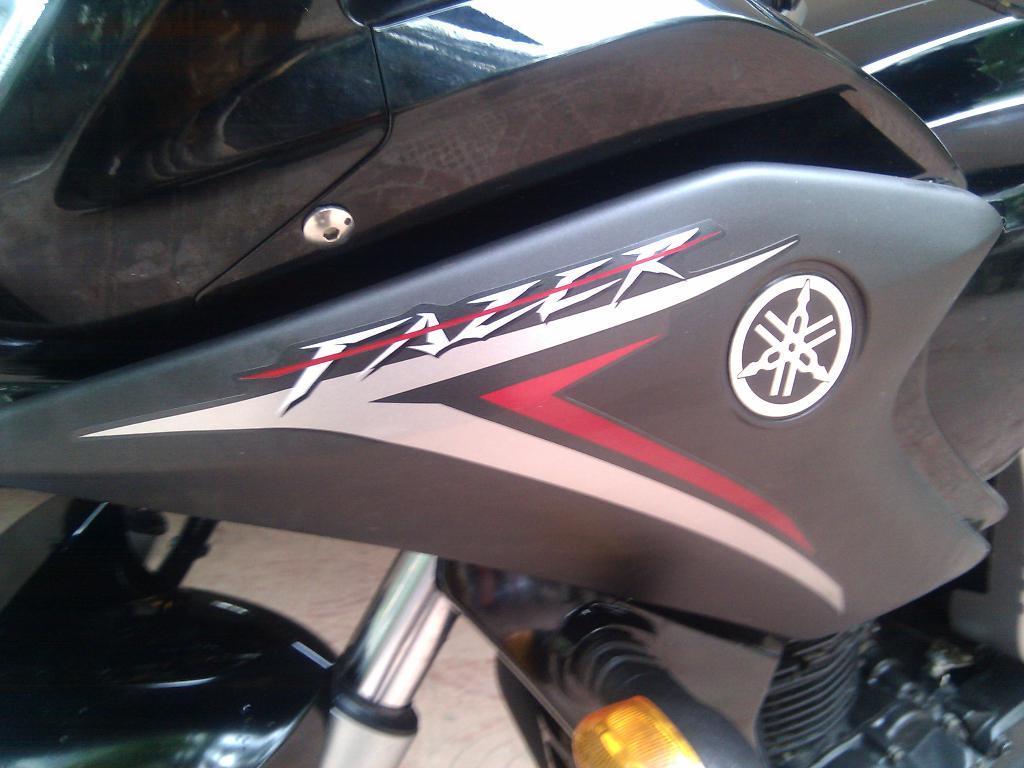Describe this image in one or two sentences. In this image we can see a bike. 